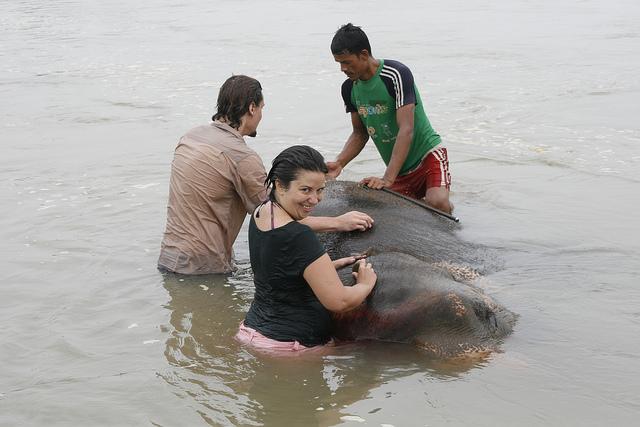How many living beings are in the picture?
Write a very short answer. 4. How many elephants are in the picture?
Quick response, please. 1. Are they standing in a river?
Quick response, please. Yes. What are the people touching?
Give a very brief answer. Hippo. Is she massaging the animal?
Quick response, please. Yes. What animal is in the water?
Write a very short answer. Elephant. What is the man holding?
Quick response, please. Elephant. What animal is the woman riding?
Answer briefly. Elephant. 